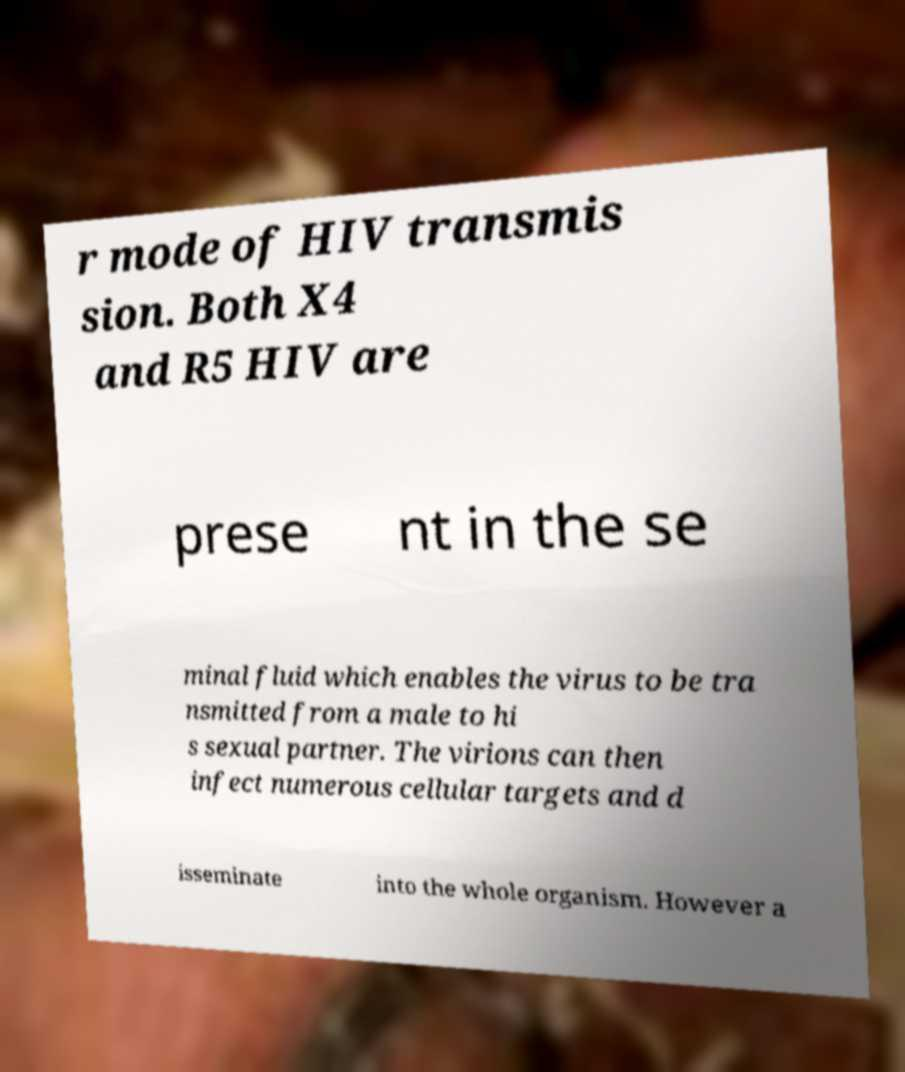For documentation purposes, I need the text within this image transcribed. Could you provide that? r mode of HIV transmis sion. Both X4 and R5 HIV are prese nt in the se minal fluid which enables the virus to be tra nsmitted from a male to hi s sexual partner. The virions can then infect numerous cellular targets and d isseminate into the whole organism. However a 